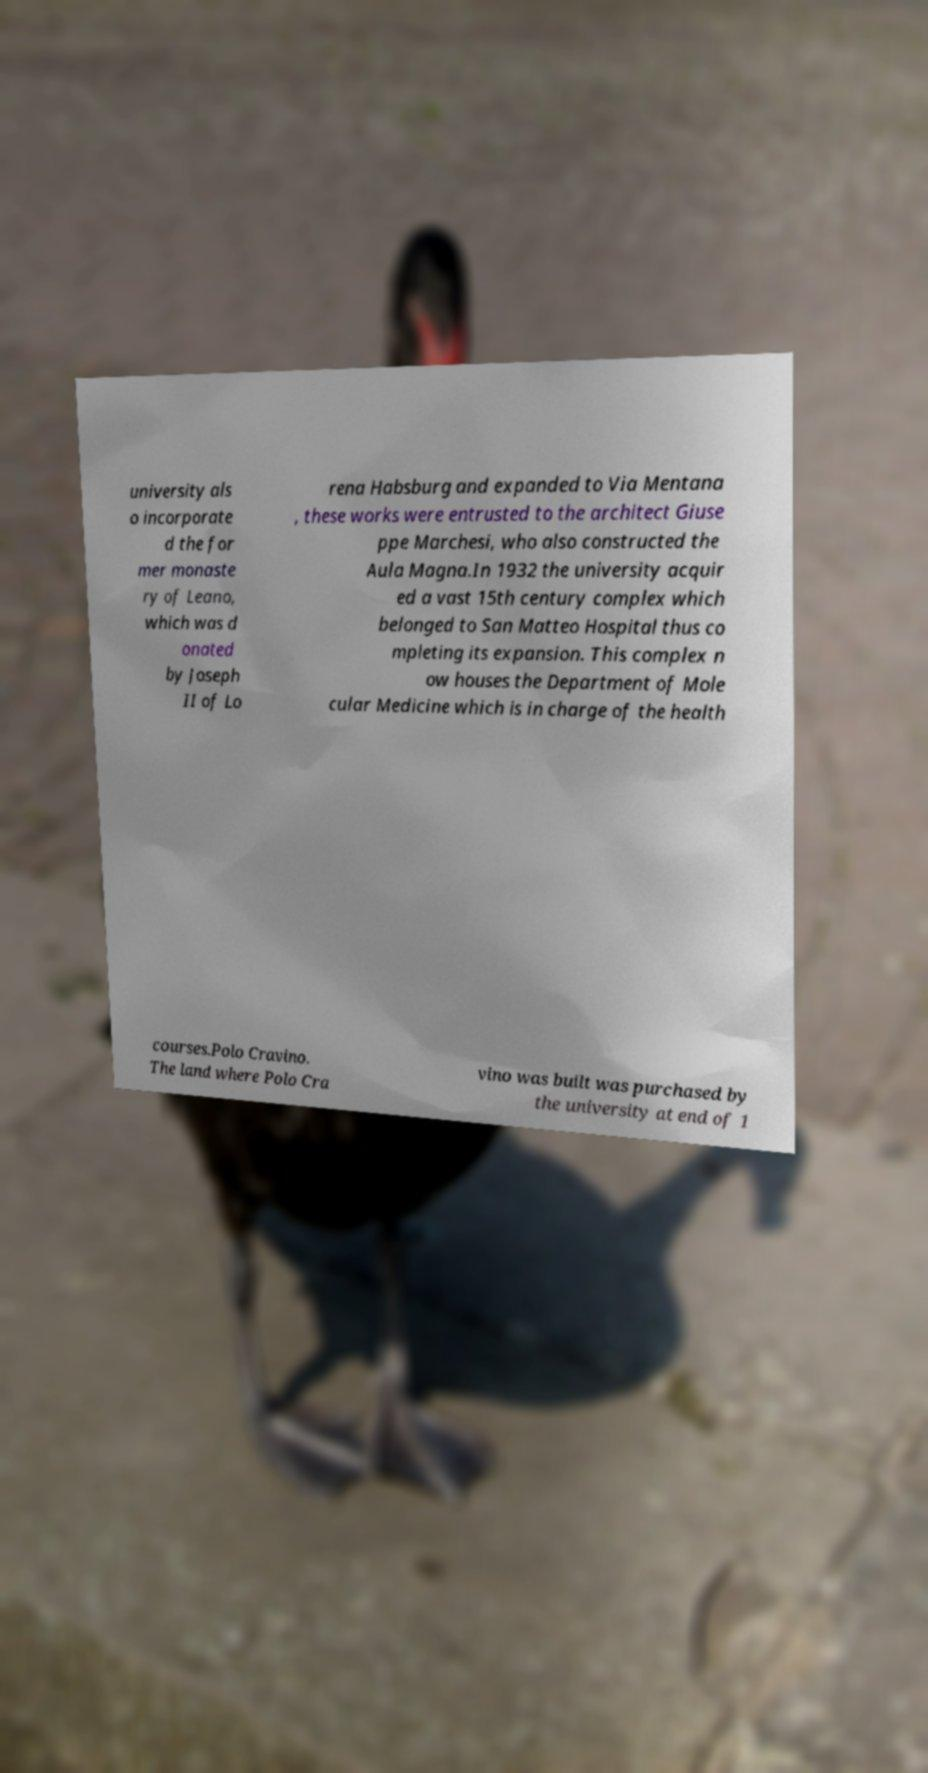For documentation purposes, I need the text within this image transcribed. Could you provide that? university als o incorporate d the for mer monaste ry of Leano, which was d onated by Joseph II of Lo rena Habsburg and expanded to Via Mentana , these works were entrusted to the architect Giuse ppe Marchesi, who also constructed the Aula Magna.In 1932 the university acquir ed a vast 15th century complex which belonged to San Matteo Hospital thus co mpleting its expansion. This complex n ow houses the Department of Mole cular Medicine which is in charge of the health courses.Polo Cravino. The land where Polo Cra vino was built was purchased by the university at end of 1 